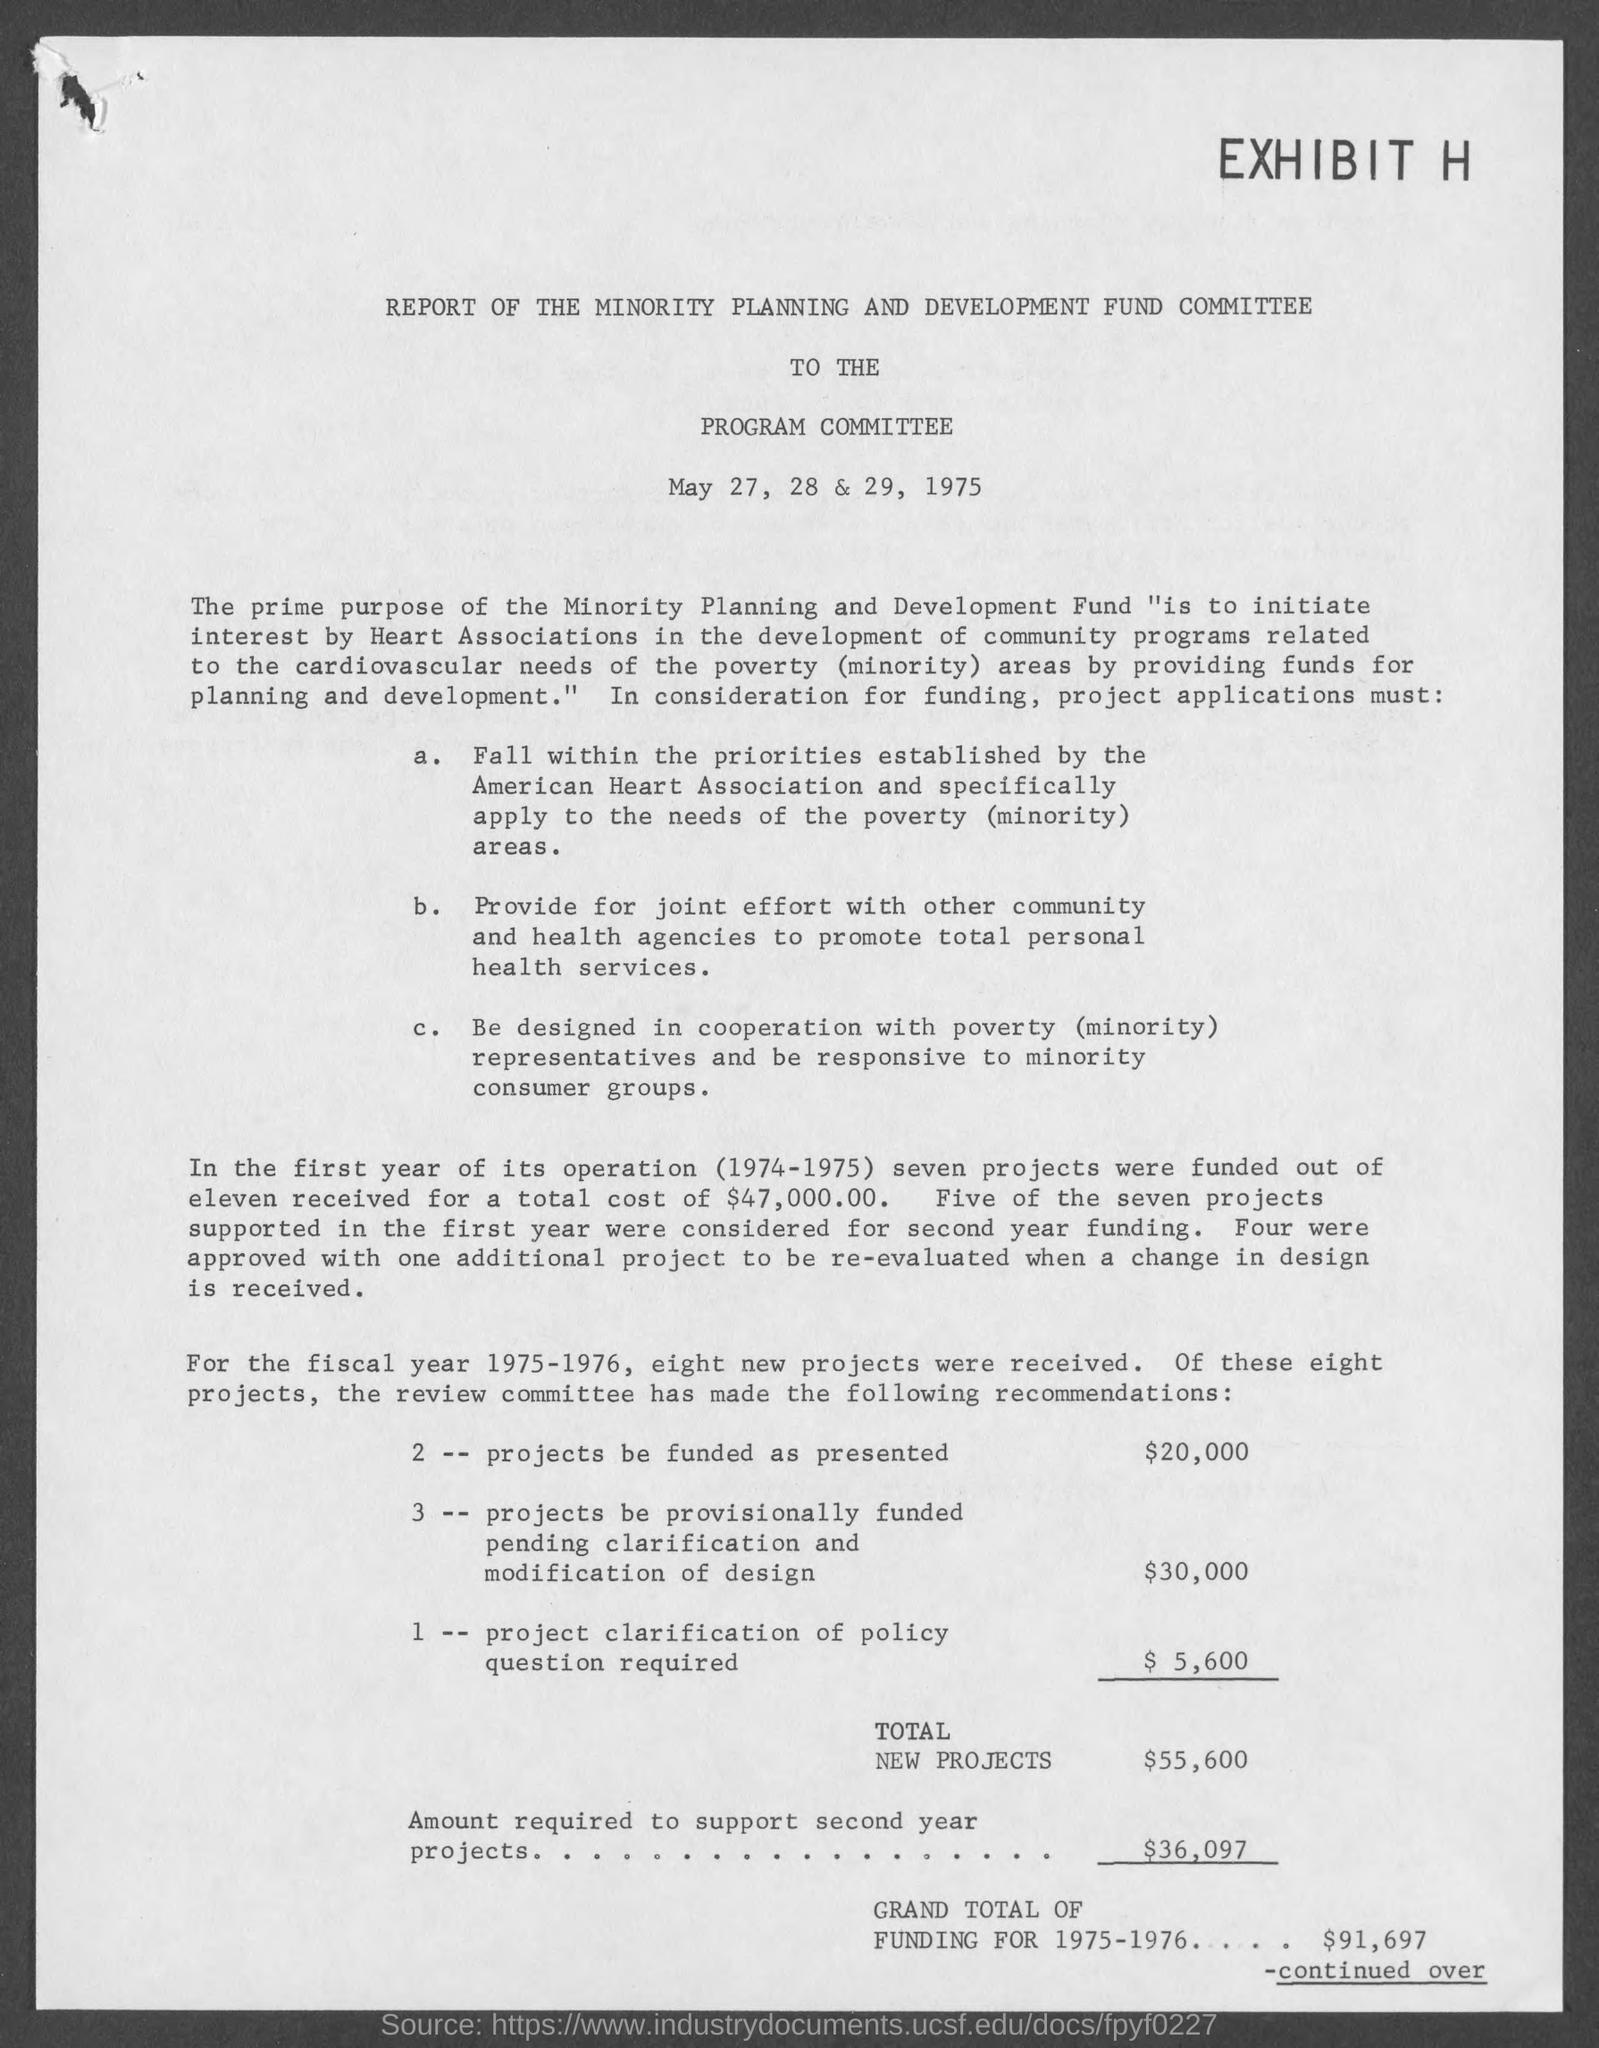Highlight a few significant elements in this photo. The total amount of new projects is 55,600. This report is addressed to the Program Committee. The amount required to support second-year projects is $36,097. The grand total of funding for the year 1975-1976 was $91,697. 